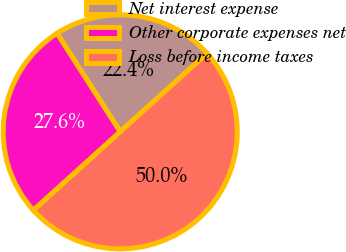Convert chart to OTSL. <chart><loc_0><loc_0><loc_500><loc_500><pie_chart><fcel>Net interest expense<fcel>Other corporate expenses net<fcel>Loss before income taxes<nl><fcel>22.38%<fcel>27.62%<fcel>50.0%<nl></chart> 